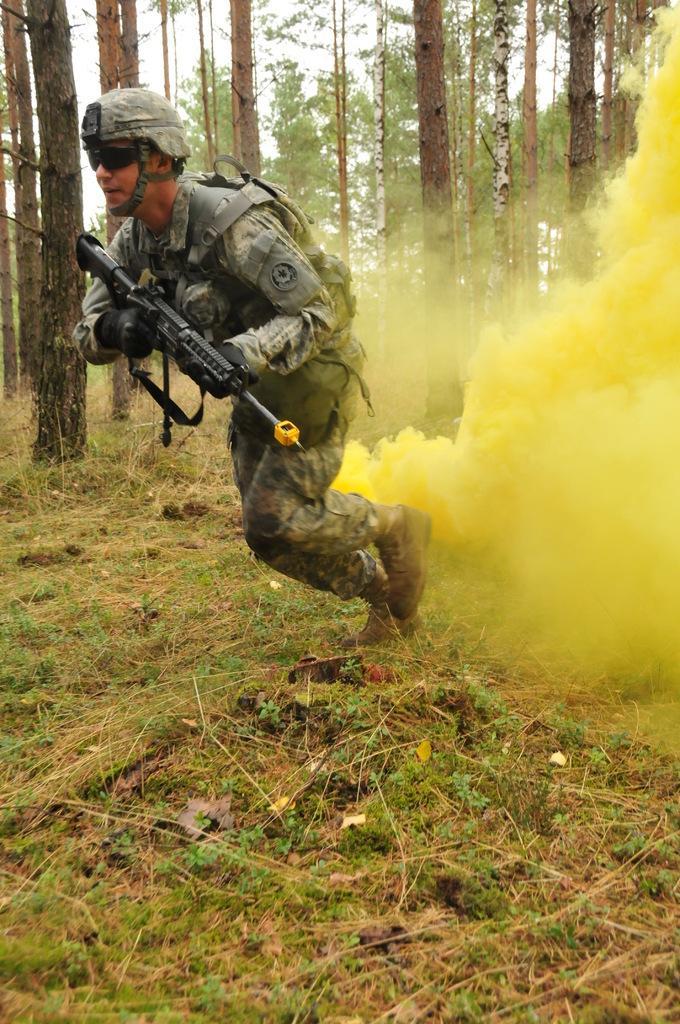Please provide a concise description of this image. In the foreground of this image, there is a man wearing a bag and helmet is holding a gun and running on the grass. Behind him, there is yellow smoke. In the background, there are trees and the sky. 